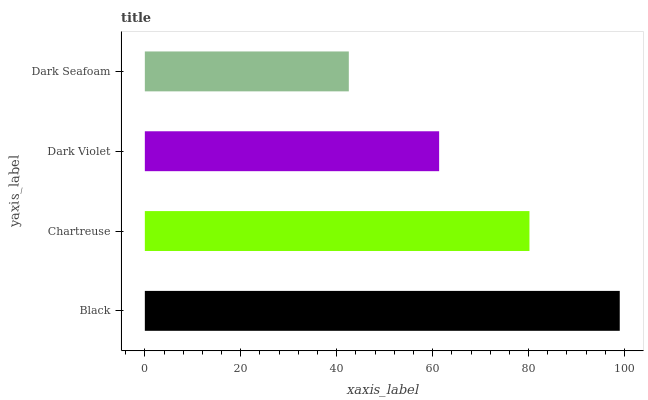Is Dark Seafoam the minimum?
Answer yes or no. Yes. Is Black the maximum?
Answer yes or no. Yes. Is Chartreuse the minimum?
Answer yes or no. No. Is Chartreuse the maximum?
Answer yes or no. No. Is Black greater than Chartreuse?
Answer yes or no. Yes. Is Chartreuse less than Black?
Answer yes or no. Yes. Is Chartreuse greater than Black?
Answer yes or no. No. Is Black less than Chartreuse?
Answer yes or no. No. Is Chartreuse the high median?
Answer yes or no. Yes. Is Dark Violet the low median?
Answer yes or no. Yes. Is Black the high median?
Answer yes or no. No. Is Dark Seafoam the low median?
Answer yes or no. No. 